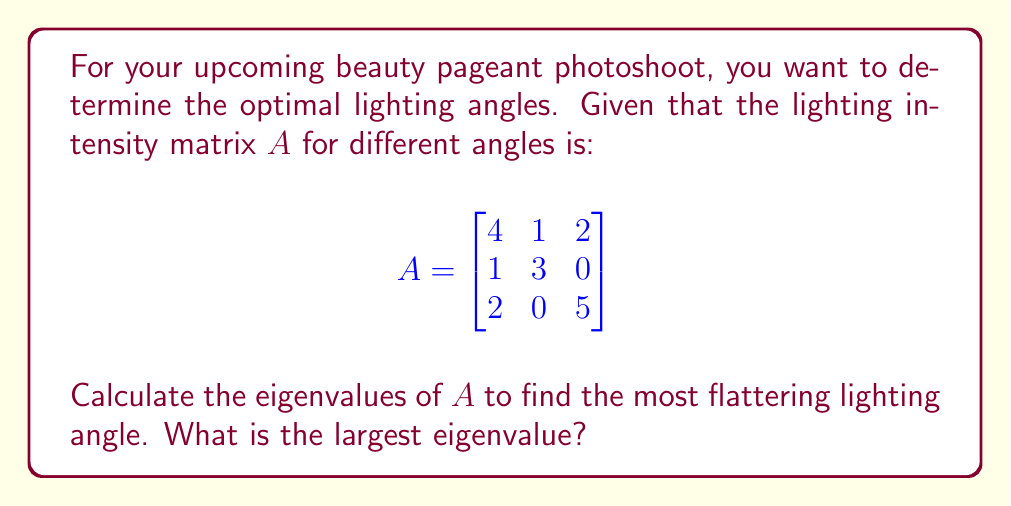Teach me how to tackle this problem. To find the eigenvalues, we need to solve the characteristic equation:

1) First, set up the equation $\det(A - \lambda I) = 0$, where $I$ is the 3x3 identity matrix:

   $$\det\begin{pmatrix}
   4-\lambda & 1 & 2 \\
   1 & 3-\lambda & 0 \\
   2 & 0 & 5-\lambda
   \end{pmatrix} = 0$$

2) Expand the determinant:
   $$(4-\lambda)(3-\lambda)(5-\lambda) - 2(3-\lambda) - 2(1)(5-\lambda) = 0$$

3) Simplify:
   $$\lambda^3 - 12\lambda^2 + 41\lambda - 38 = 0$$

4) This cubic equation can be solved using various methods. One eigenvalue is clearly visible: $\lambda = 1$ (you can verify this by substitution).

5) Using polynomial long division or the rational root theorem, we can factor out $(λ - 1)$:
   $$(\lambda - 1)(\lambda^2 - 11\lambda + 38) = 0$$

6) Solve the quadratic equation $\lambda^2 - 11\lambda + 38 = 0$ using the quadratic formula:
   $$\lambda = \frac{11 \pm \sqrt{121 - 152}}{2} = \frac{11 \pm \sqrt{-31}}{2}$$

7) The eigenvalues are therefore:
   $\lambda_1 = 1$
   $\lambda_2 = \frac{11 + \sqrt{31}i}{2}$
   $\lambda_3 = \frac{11 - \sqrt{31}i}{2}$

8) The largest eigenvalue in magnitude is $\lambda_2 = \lambda_3 = \frac{11 + \sqrt{31}i}{2}$, with a magnitude of $\sqrt{(\frac{11}{2})^2 + (\frac{\sqrt{31}}{2})^2} = \sqrt{\frac{121+31}{4}} = \sqrt{38} \approx 6.16$

Therefore, the largest eigenvalue is $\sqrt{38}$.
Answer: $\sqrt{38}$ 